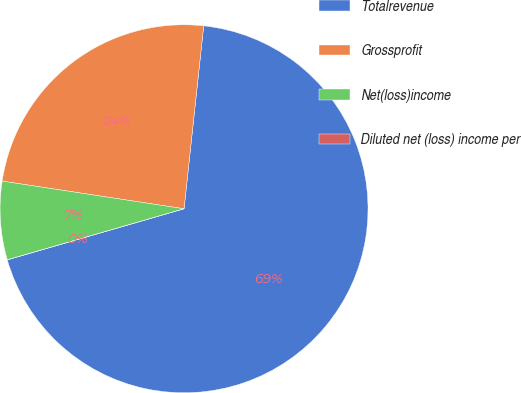Convert chart. <chart><loc_0><loc_0><loc_500><loc_500><pie_chart><fcel>Totalrevenue<fcel>Grossprofit<fcel>Net(loss)income<fcel>Diluted net (loss) income per<nl><fcel>68.82%<fcel>24.3%<fcel>6.88%<fcel>0.0%<nl></chart> 